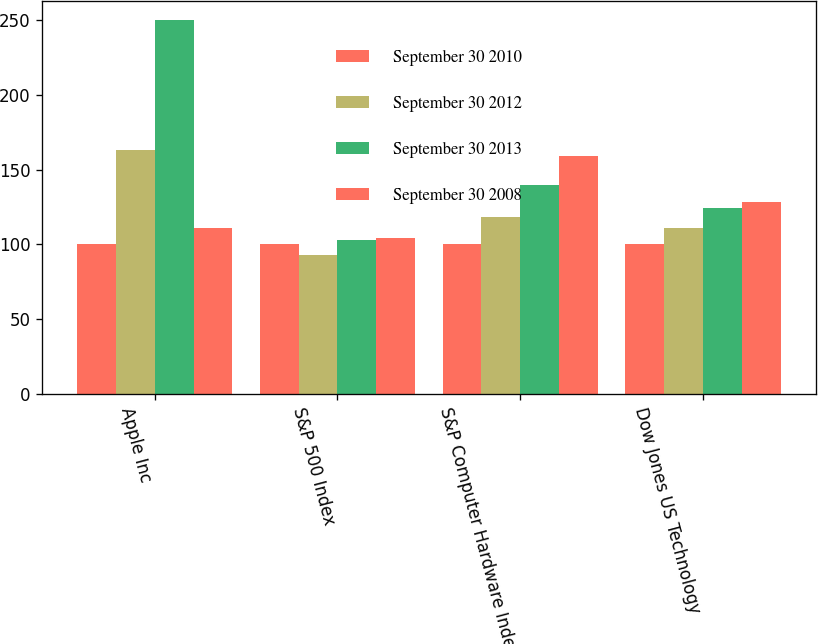Convert chart to OTSL. <chart><loc_0><loc_0><loc_500><loc_500><stacked_bar_chart><ecel><fcel>Apple Inc<fcel>S&P 500 Index<fcel>S&P Computer Hardware Index<fcel>Dow Jones US Technology<nl><fcel>September 30 2010<fcel>100<fcel>100<fcel>100<fcel>100<nl><fcel>September 30 2012<fcel>163<fcel>93<fcel>118<fcel>111<nl><fcel>September 30 2013<fcel>250<fcel>103<fcel>140<fcel>124<nl><fcel>September 30 2008<fcel>111<fcel>104<fcel>159<fcel>128<nl></chart> 